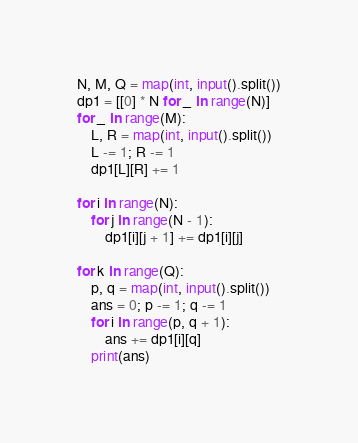Convert code to text. <code><loc_0><loc_0><loc_500><loc_500><_Python_>N, M, Q = map(int, input().split())
dp1 = [[0] * N for _ in range(N)]
for _ in range(M):
    L, R = map(int, input().split())
    L -= 1; R -= 1
    dp1[L][R] += 1

for i in range(N):
    for j in range(N - 1):
        dp1[i][j + 1] += dp1[i][j]

for k in range(Q):
    p, q = map(int, input().split())
    ans = 0; p -= 1; q -= 1
    for i in range(p, q + 1):
        ans += dp1[i][q]
    print(ans)
</code> 